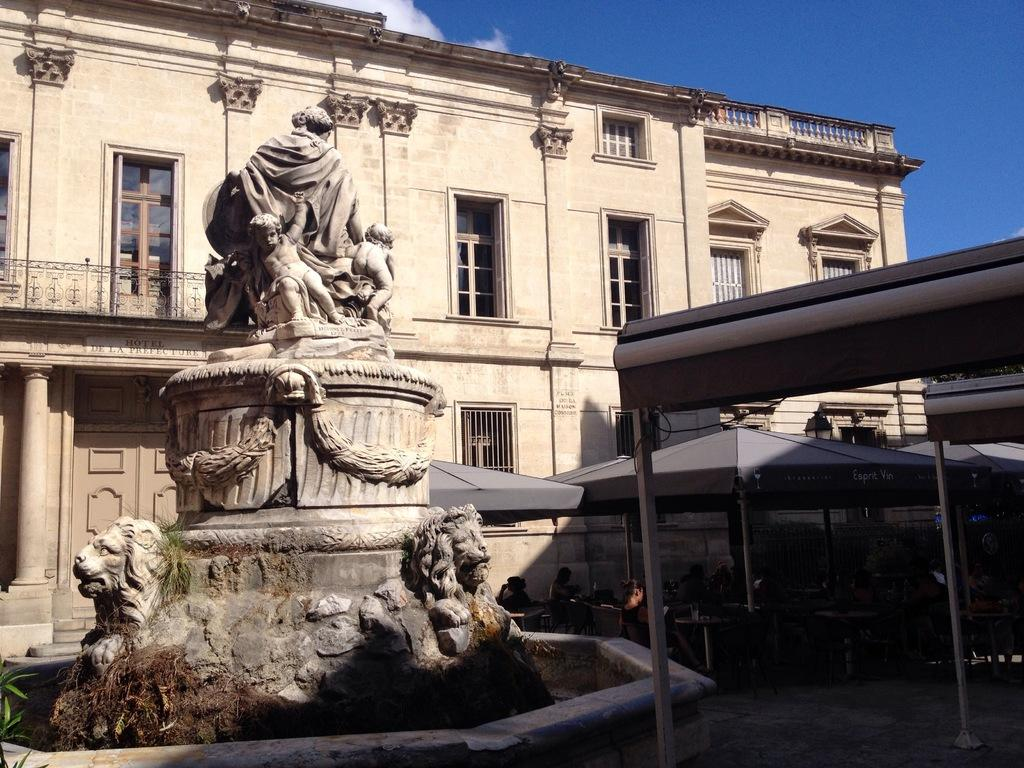What is the main object or figure in the image? There is a statue in the image. What type of temporary shelters can be seen in the image? There are tents in the image. What are the poles used for in the image? The poles are likely used for supporting the tents or other structures. What type of building is visible in the image? There is a building with windows in the image. Who or what is present in the image? There are people in the image. What can be seen in the background of the image? The sky is visible in the background of the image. What type of office is the lawyer working in within the image? There is no office or lawyer present in the image; it features a statue, tents, poles, a building, and people. What sound does the whistle make in the image? There is no whistle present in the image. 